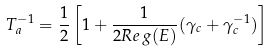Convert formula to latex. <formula><loc_0><loc_0><loc_500><loc_500>T _ { a } ^ { - 1 } = \frac { 1 } { 2 } \left [ 1 + \frac { 1 } { 2 R e \, g ( E ) } ( \gamma _ { c } + \gamma _ { c } ^ { - 1 } ) \right ]</formula> 